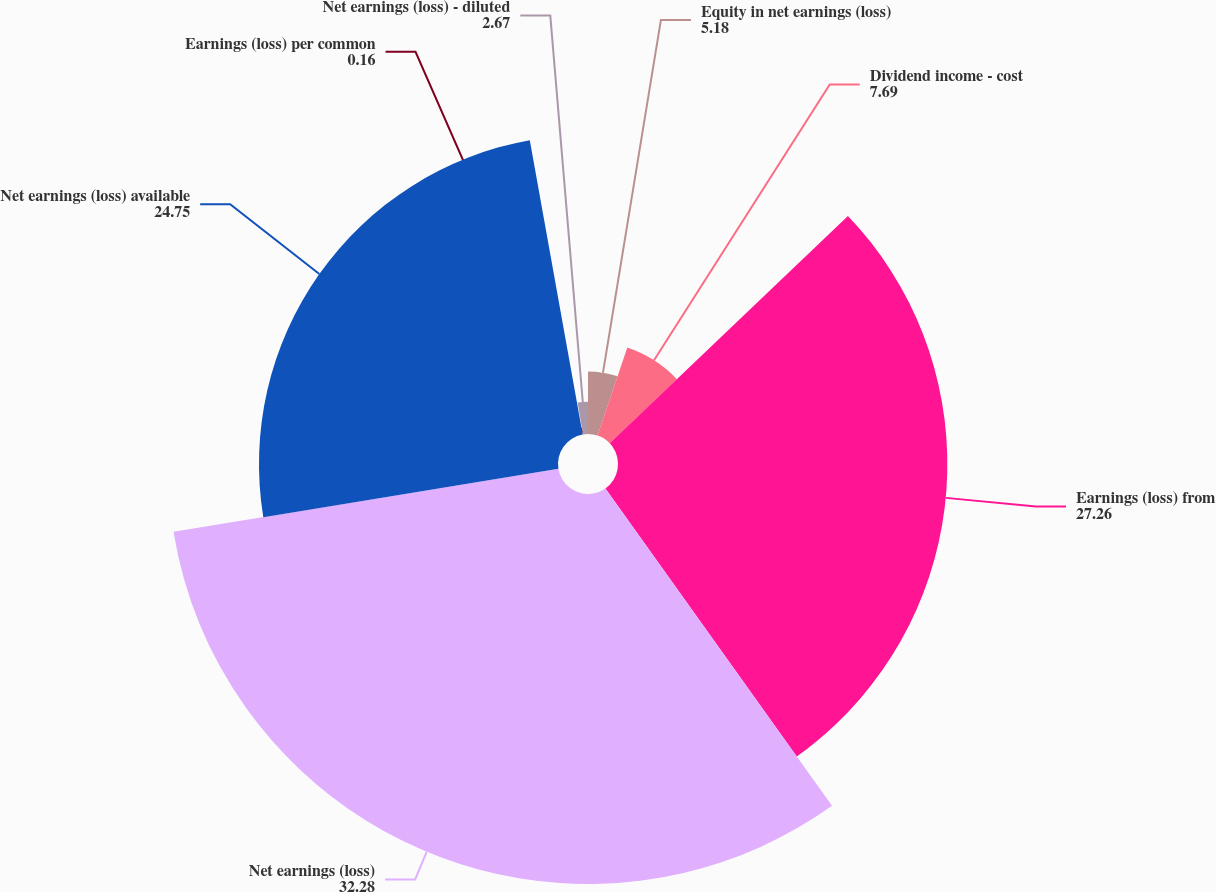Convert chart. <chart><loc_0><loc_0><loc_500><loc_500><pie_chart><fcel>Equity in net earnings (loss)<fcel>Dividend income - cost<fcel>Earnings (loss) from<fcel>Net earnings (loss)<fcel>Net earnings (loss) available<fcel>Earnings (loss) per common<fcel>Net earnings (loss) - diluted<nl><fcel>5.18%<fcel>7.69%<fcel>27.26%<fcel>32.28%<fcel>24.75%<fcel>0.16%<fcel>2.67%<nl></chart> 